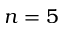<formula> <loc_0><loc_0><loc_500><loc_500>n = 5</formula> 